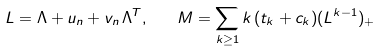Convert formula to latex. <formula><loc_0><loc_0><loc_500><loc_500>L = \Lambda + u _ { n } + v _ { n } \, \Lambda ^ { T } , \quad M = \sum _ { k \geq 1 } k \, ( t _ { k } + c _ { k } ) ( L ^ { k - 1 } ) _ { + }</formula> 